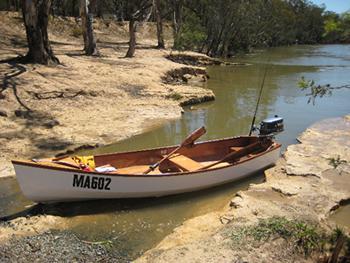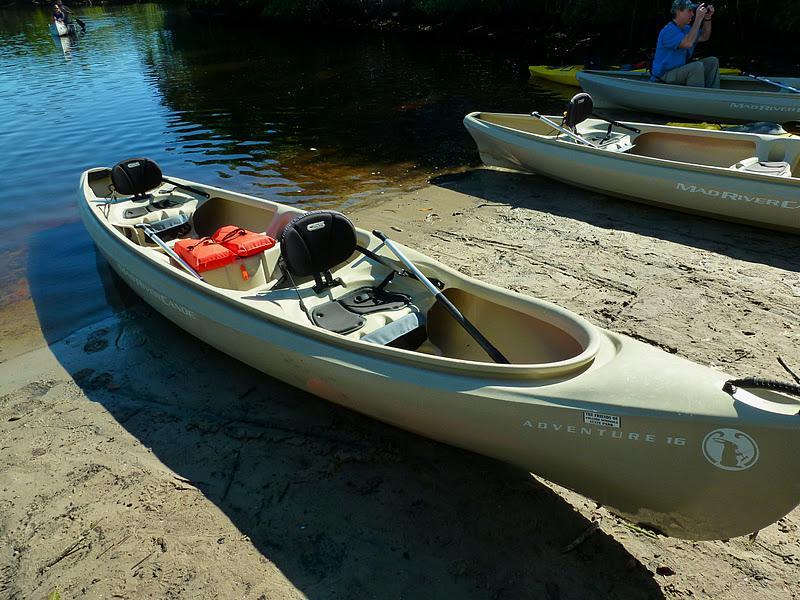The first image is the image on the left, the second image is the image on the right. Analyze the images presented: Is the assertion "Each image shows in the foreground a boat containing gear pulled up to the water's edge so it is partly on ground." valid? Answer yes or no. Yes. The first image is the image on the left, the second image is the image on the right. Assess this claim about the two images: "At least one person is sitting in a canoe in the image on the right.". Correct or not? Answer yes or no. Yes. 